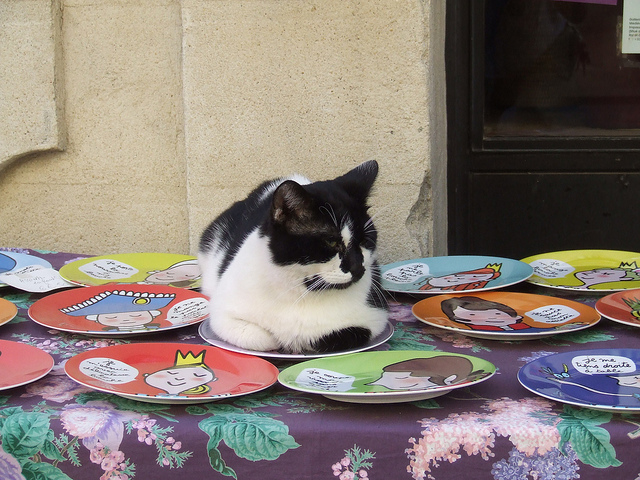Identify the text contained in this image. dnonta 